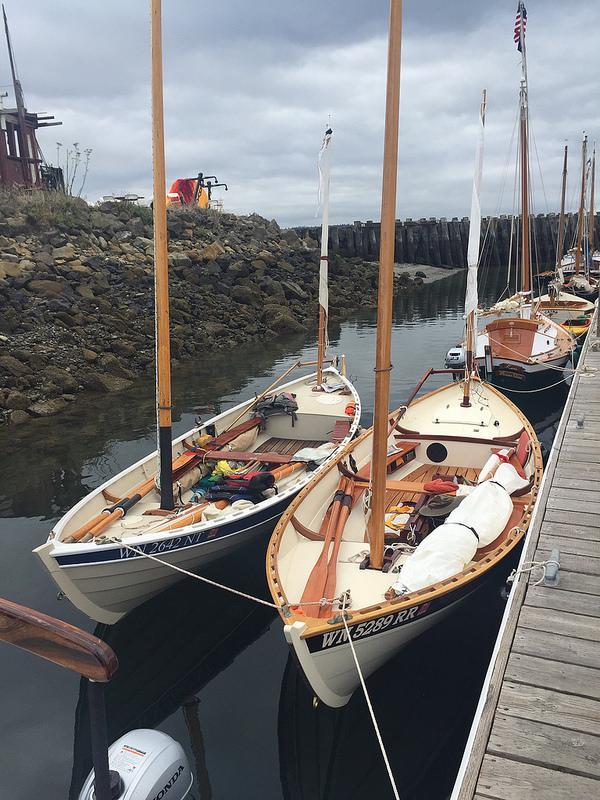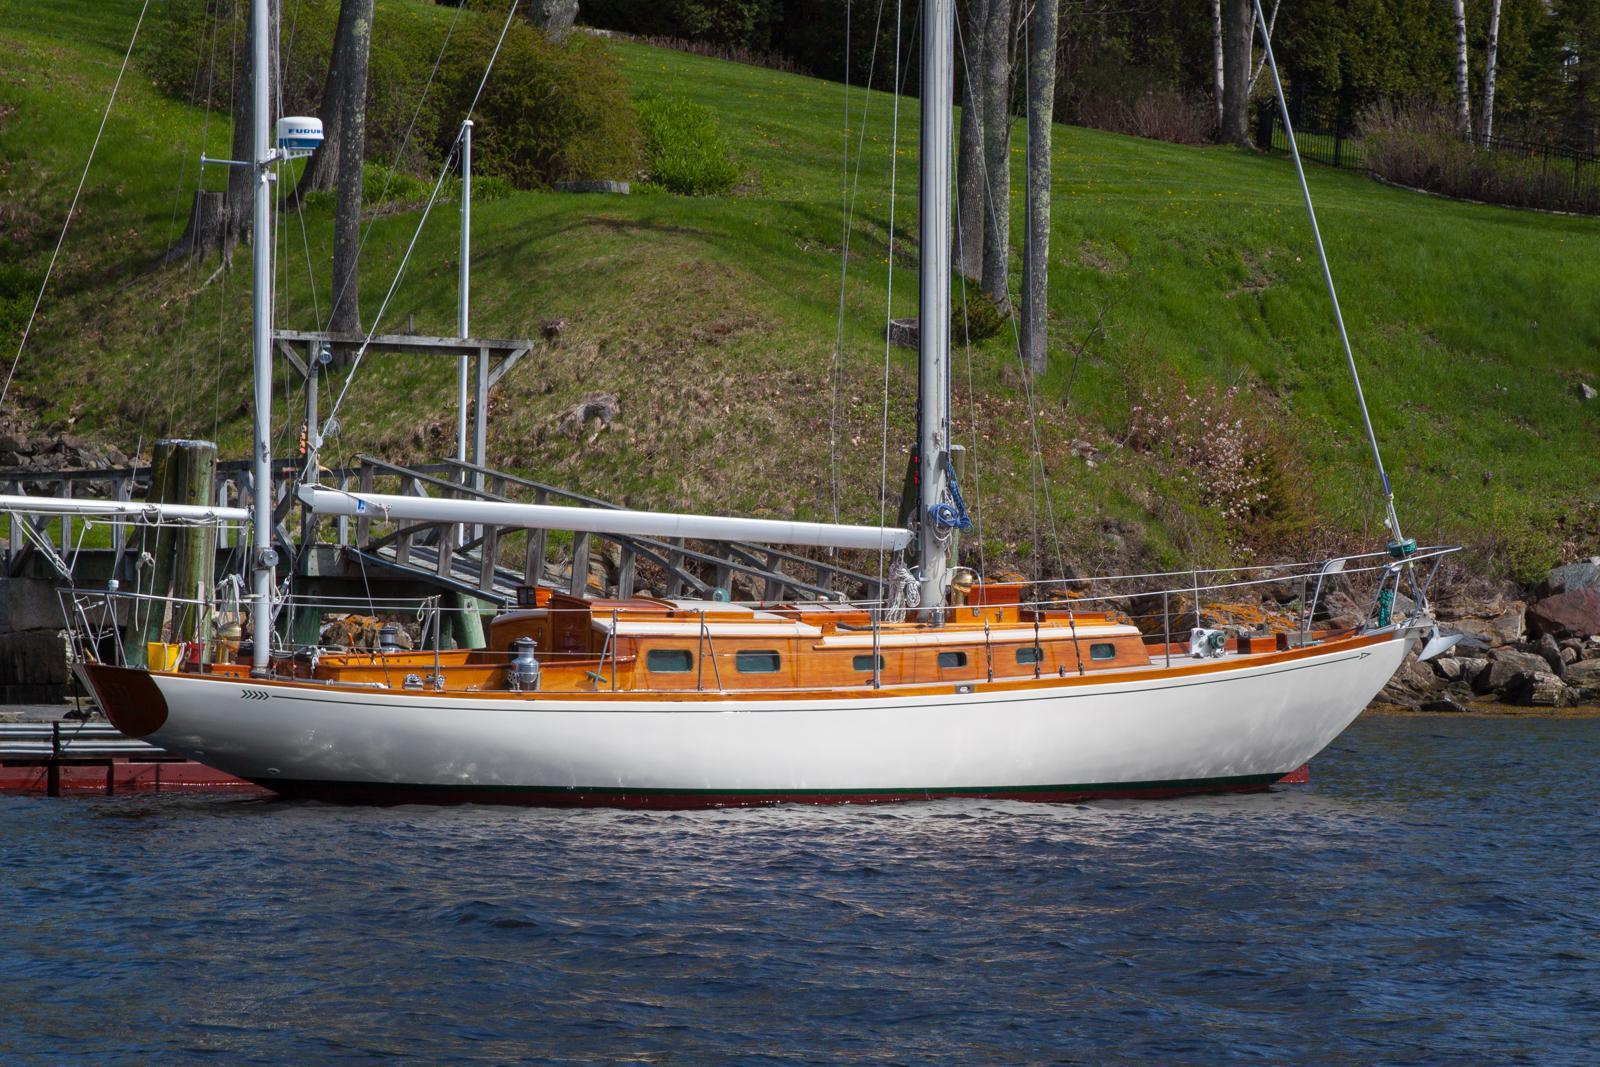The first image is the image on the left, the second image is the image on the right. For the images displayed, is the sentence "Boats are parked by a wooden pier." factually correct? Answer yes or no. Yes. 